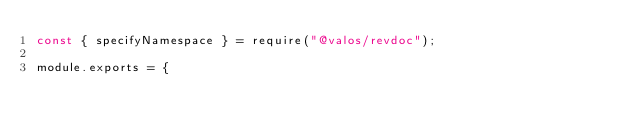<code> <loc_0><loc_0><loc_500><loc_500><_JavaScript_>const { specifyNamespace } = require("@valos/revdoc");

module.exports = {</code> 